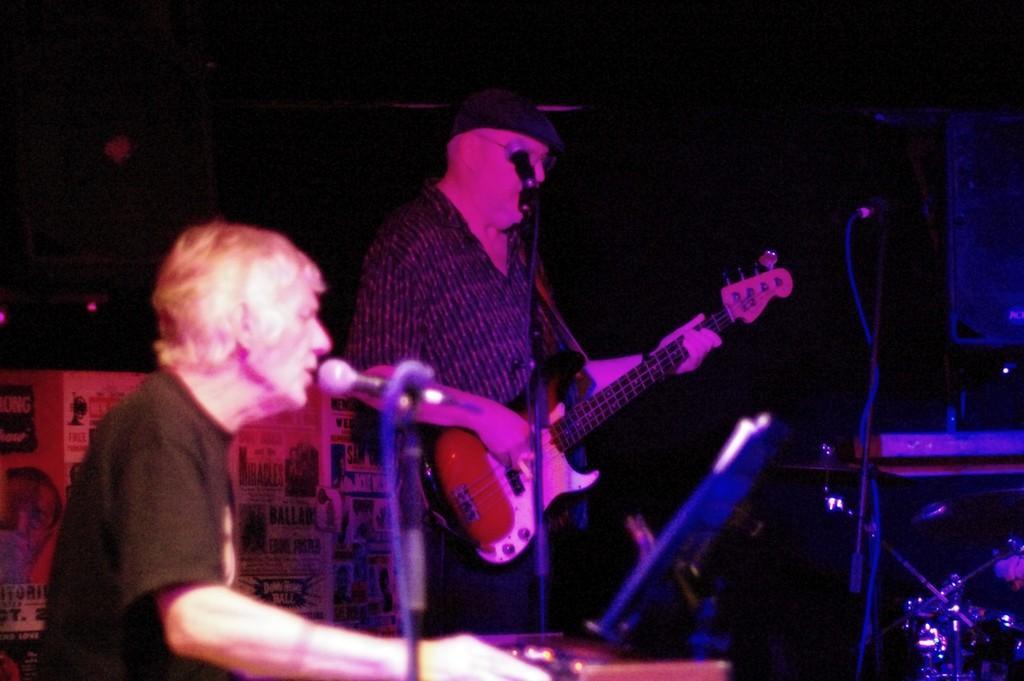Could you give a brief overview of what you see in this image? There are two people and this man playing guitar. We can see microphones with stands, musical instrument and device. In the background it is dark and we can see banner. 